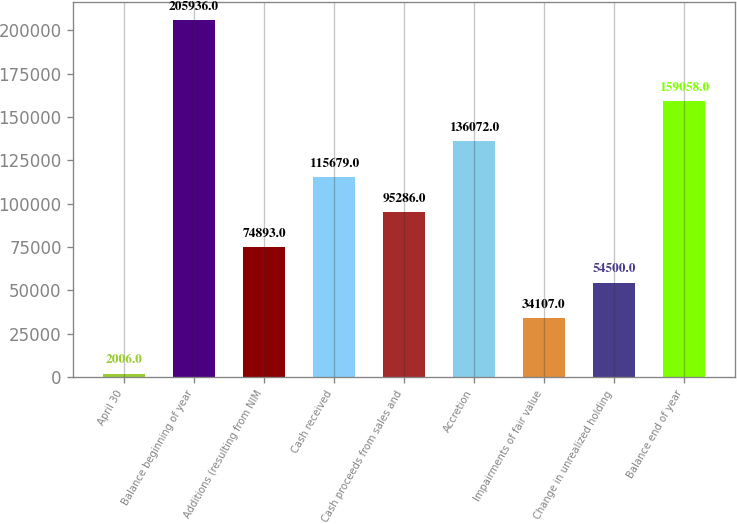<chart> <loc_0><loc_0><loc_500><loc_500><bar_chart><fcel>April 30<fcel>Balance beginning of year<fcel>Additions (resulting from NIM<fcel>Cash received<fcel>Cash proceeds from sales and<fcel>Accretion<fcel>Impairments of fair value<fcel>Change in unrealized holding<fcel>Balance end of year<nl><fcel>2006<fcel>205936<fcel>74893<fcel>115679<fcel>95286<fcel>136072<fcel>34107<fcel>54500<fcel>159058<nl></chart> 